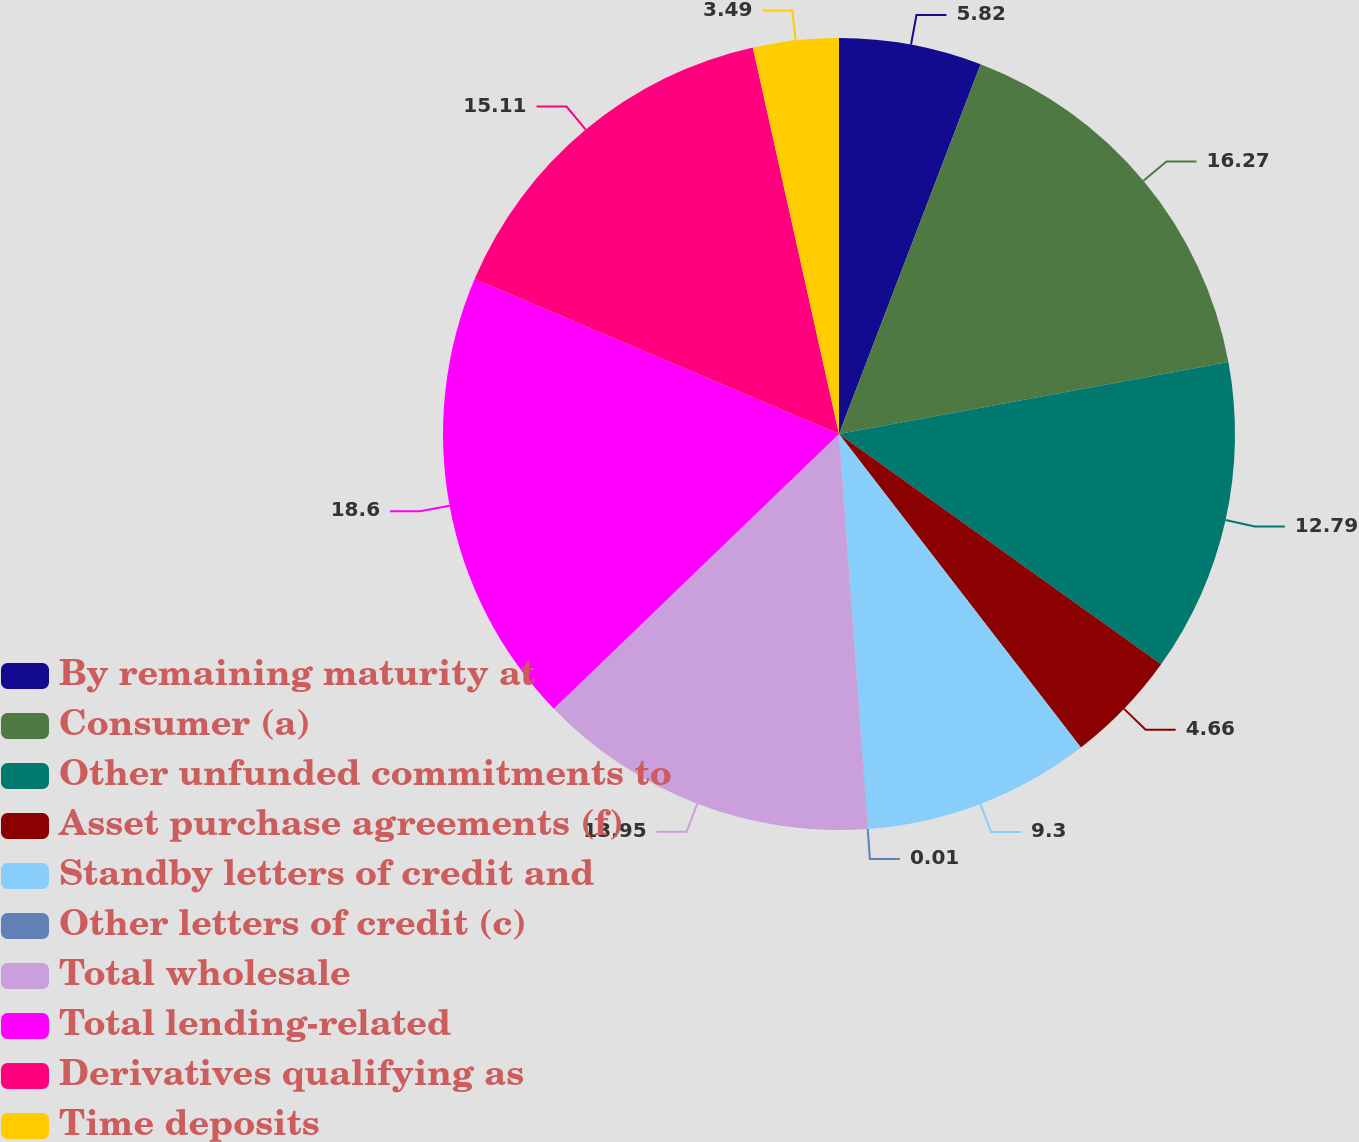<chart> <loc_0><loc_0><loc_500><loc_500><pie_chart><fcel>By remaining maturity at<fcel>Consumer (a)<fcel>Other unfunded commitments to<fcel>Asset purchase agreements (f)<fcel>Standby letters of credit and<fcel>Other letters of credit (c)<fcel>Total wholesale<fcel>Total lending-related<fcel>Derivatives qualifying as<fcel>Time deposits<nl><fcel>5.82%<fcel>16.27%<fcel>12.79%<fcel>4.66%<fcel>9.3%<fcel>0.01%<fcel>13.95%<fcel>18.6%<fcel>15.11%<fcel>3.49%<nl></chart> 